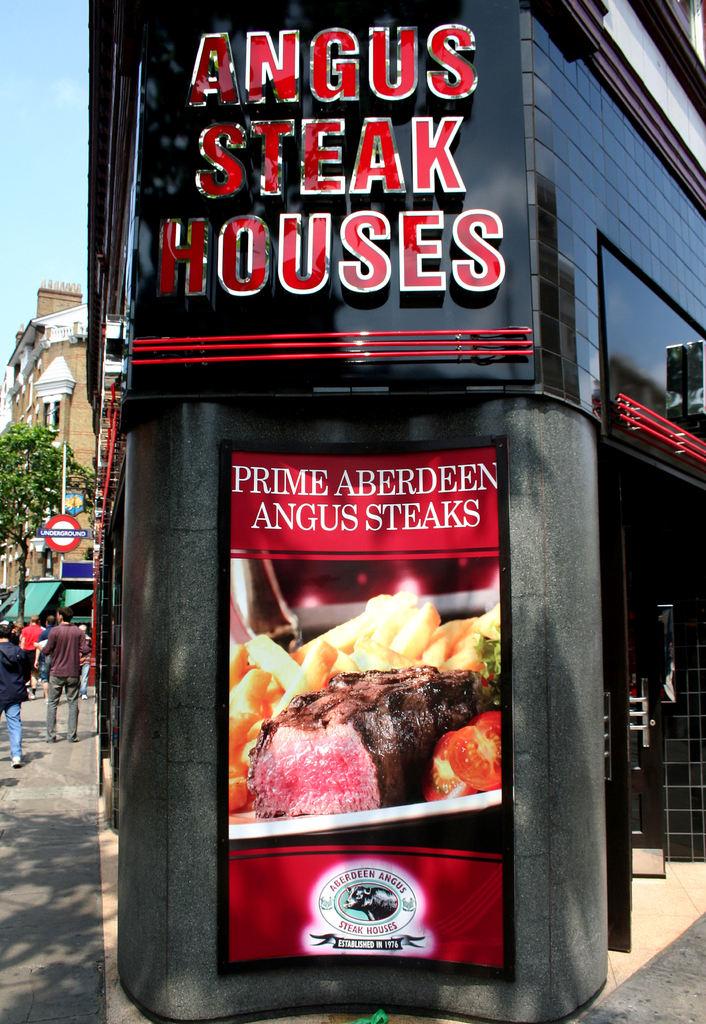Is this a steak house?
Keep it short and to the point. Yes. What kind of steak house?
Offer a very short reply. Angus. 